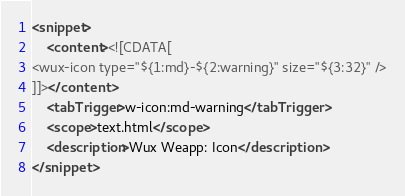<code> <loc_0><loc_0><loc_500><loc_500><_XML_><snippet>
	<content><![CDATA[
<wux-icon type="${1:md}-${2:warning}" size="${3:32}" />
]]></content>
	<tabTrigger>w-icon:md-warning</tabTrigger>
	<scope>text.html</scope>
	<description>Wux Weapp: Icon</description>
</snippet></code> 